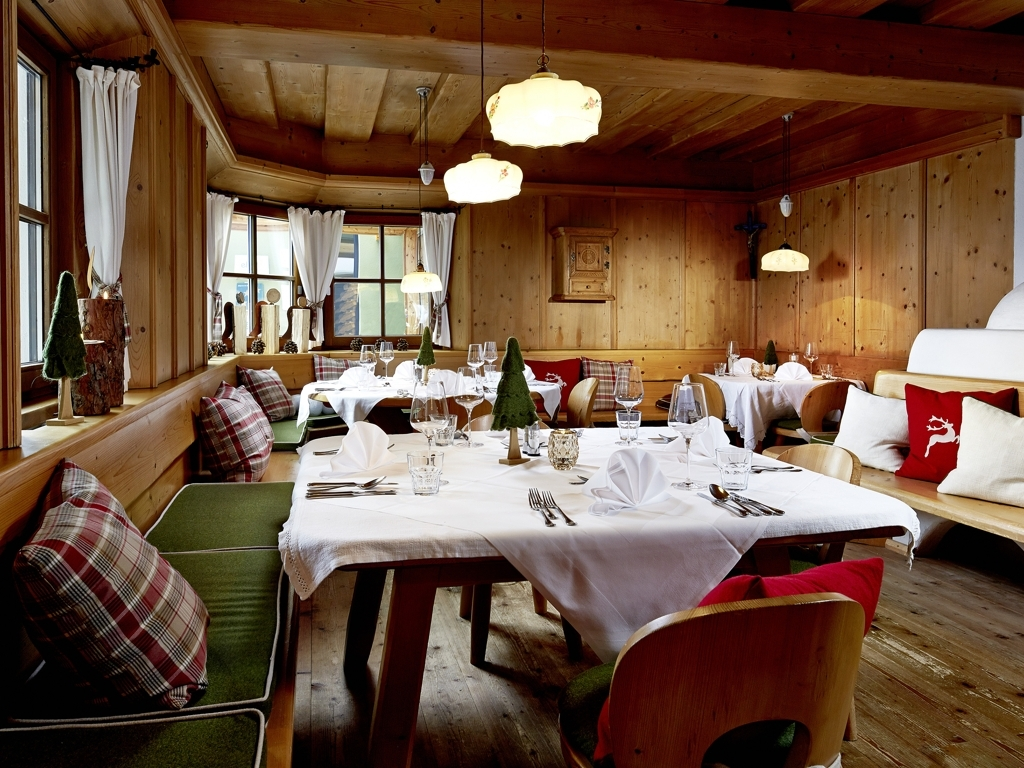How clear is the shooting scene?
A. The shooting scene is obstructed.
B. The shooting scene is out of focus.
C. The shooting scene is clear.
Answer with the option's letter from the given choices directly.
 C. 